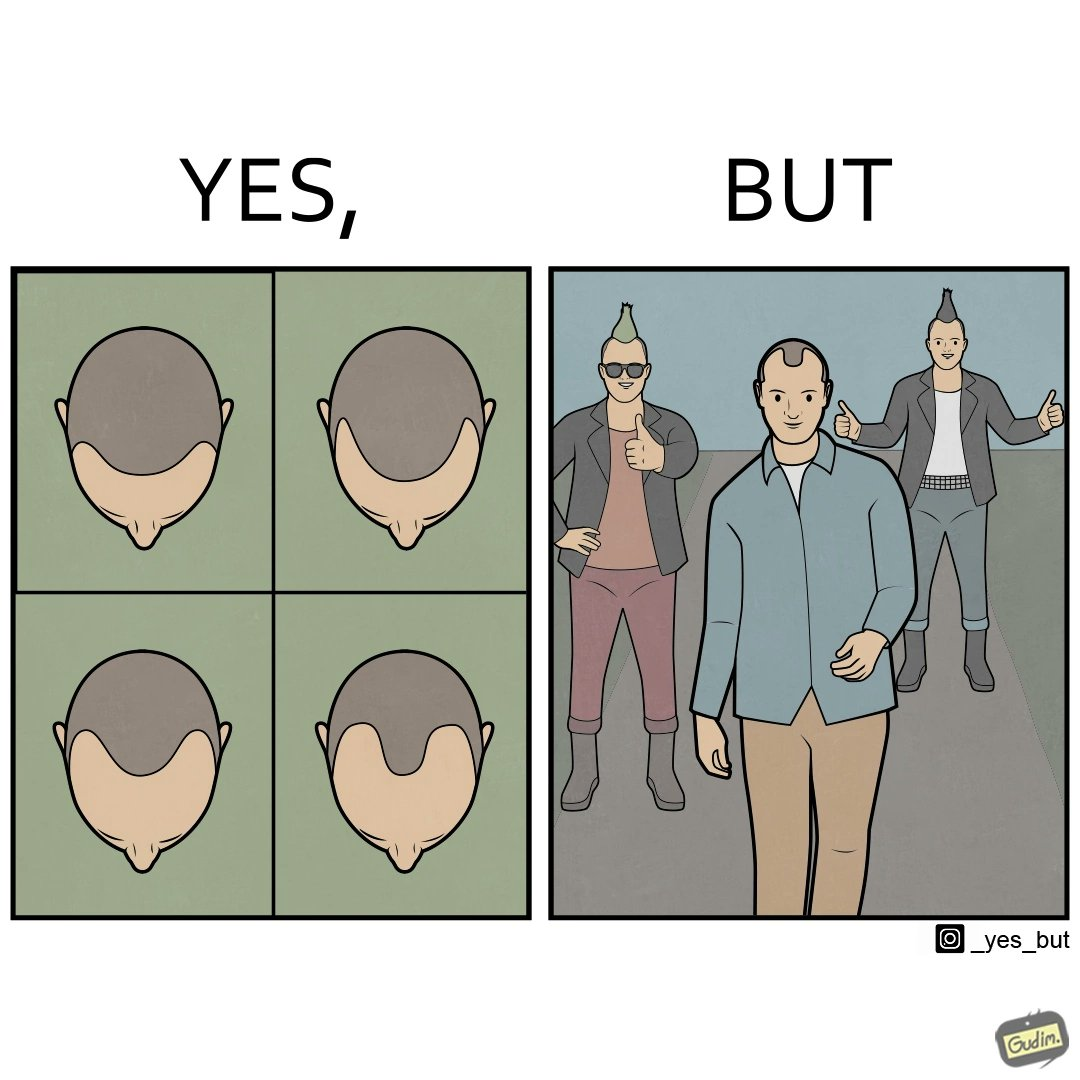Describe what you see in this image. The images are funny since they show how new hairstyles are closely resembling pattern baldness 